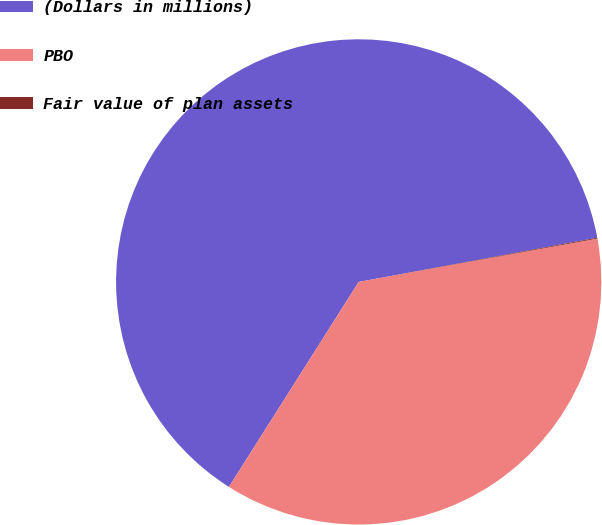<chart> <loc_0><loc_0><loc_500><loc_500><pie_chart><fcel>(Dollars in millions)<fcel>PBO<fcel>Fair value of plan assets<nl><fcel>63.1%<fcel>36.84%<fcel>0.06%<nl></chart> 